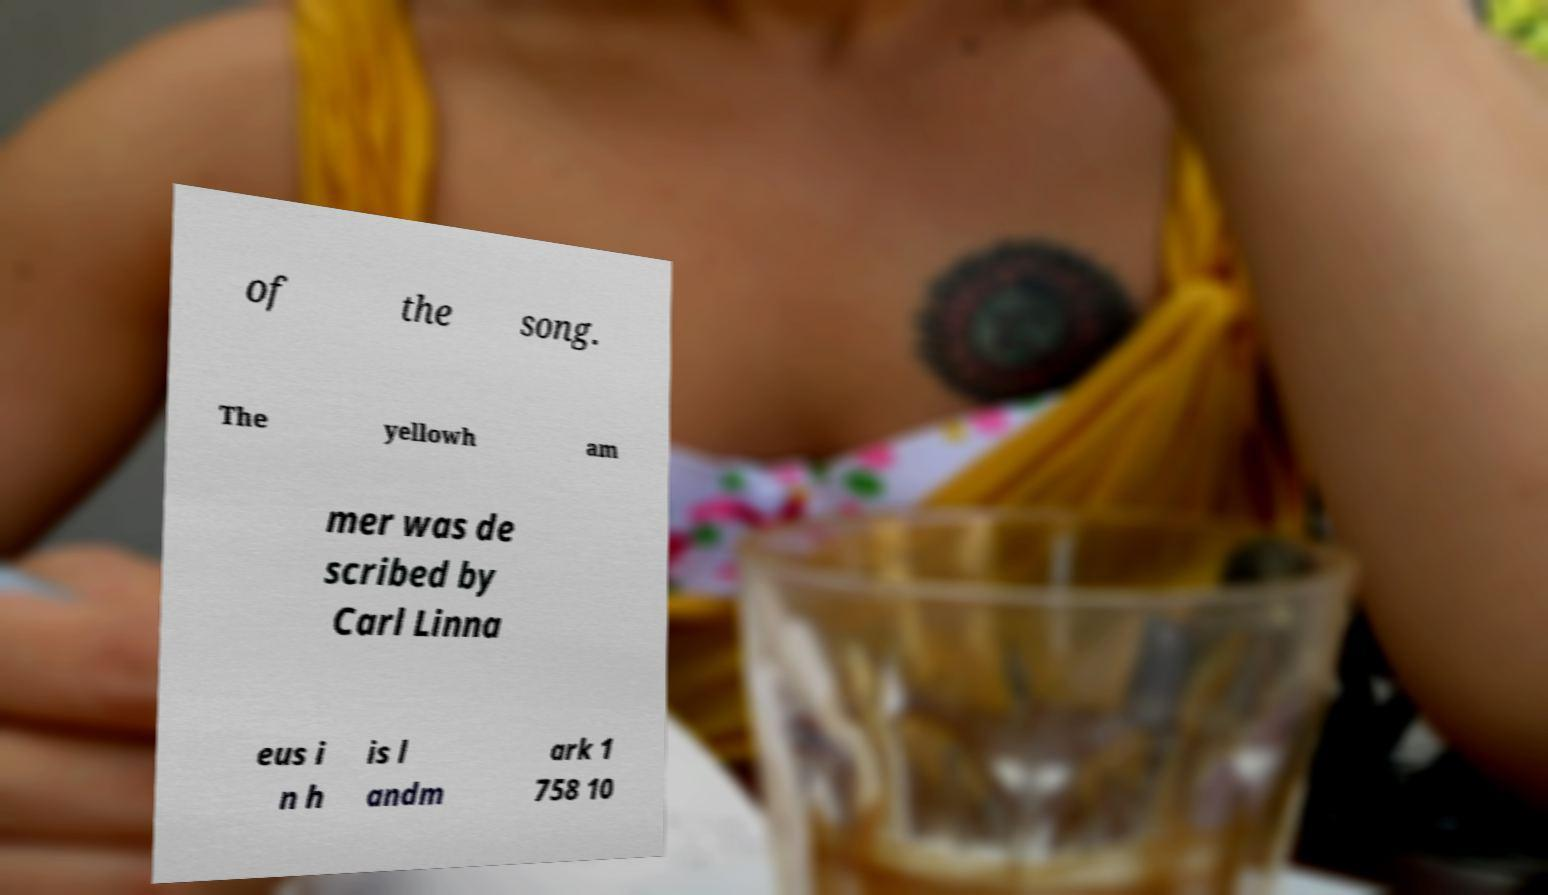Can you read and provide the text displayed in the image?This photo seems to have some interesting text. Can you extract and type it out for me? of the song. The yellowh am mer was de scribed by Carl Linna eus i n h is l andm ark 1 758 10 